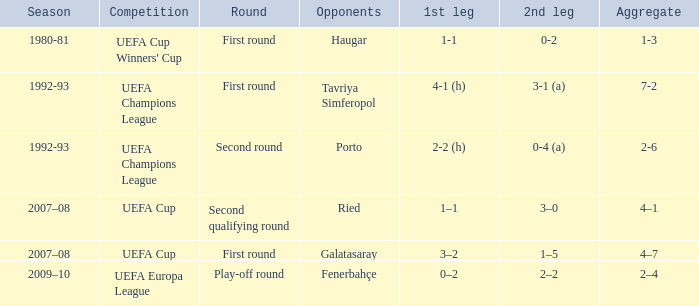What is the complete number of rounds where opponents consist of haugar? 1.0. 